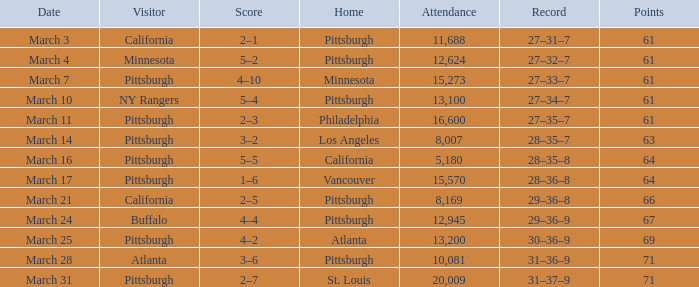What is the Date of the game in Vancouver? March 17. Can you parse all the data within this table? {'header': ['Date', 'Visitor', 'Score', 'Home', 'Attendance', 'Record', 'Points'], 'rows': [['March 3', 'California', '2–1', 'Pittsburgh', '11,688', '27–31–7', '61'], ['March 4', 'Minnesota', '5–2', 'Pittsburgh', '12,624', '27–32–7', '61'], ['March 7', 'Pittsburgh', '4–10', 'Minnesota', '15,273', '27–33–7', '61'], ['March 10', 'NY Rangers', '5–4', 'Pittsburgh', '13,100', '27–34–7', '61'], ['March 11', 'Pittsburgh', '2–3', 'Philadelphia', '16,600', '27–35–7', '61'], ['March 14', 'Pittsburgh', '3–2', 'Los Angeles', '8,007', '28–35–7', '63'], ['March 16', 'Pittsburgh', '5–5', 'California', '5,180', '28–35–8', '64'], ['March 17', 'Pittsburgh', '1–6', 'Vancouver', '15,570', '28–36–8', '64'], ['March 21', 'California', '2–5', 'Pittsburgh', '8,169', '29–36–8', '66'], ['March 24', 'Buffalo', '4–4', 'Pittsburgh', '12,945', '29–36–9', '67'], ['March 25', 'Pittsburgh', '4–2', 'Atlanta', '13,200', '30–36–9', '69'], ['March 28', 'Atlanta', '3–6', 'Pittsburgh', '10,081', '31–36–9', '71'], ['March 31', 'Pittsburgh', '2–7', 'St. Louis', '20,009', '31–37–9', '71']]} 